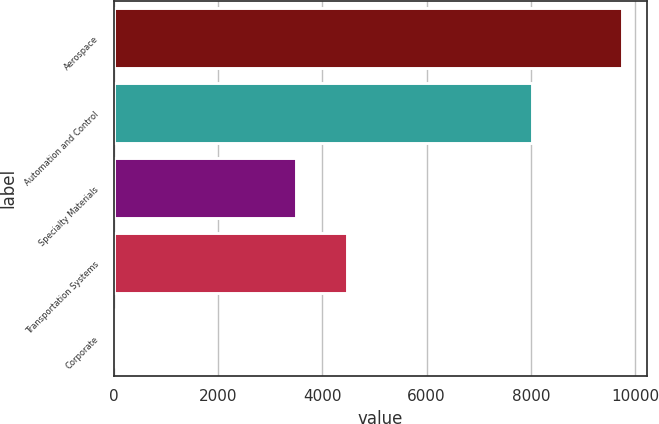Convert chart to OTSL. <chart><loc_0><loc_0><loc_500><loc_500><bar_chart><fcel>Aerospace<fcel>Automation and Control<fcel>Specialty Materials<fcel>Transportation Systems<fcel>Corporate<nl><fcel>9748<fcel>8031<fcel>3497<fcel>4471.6<fcel>2<nl></chart> 